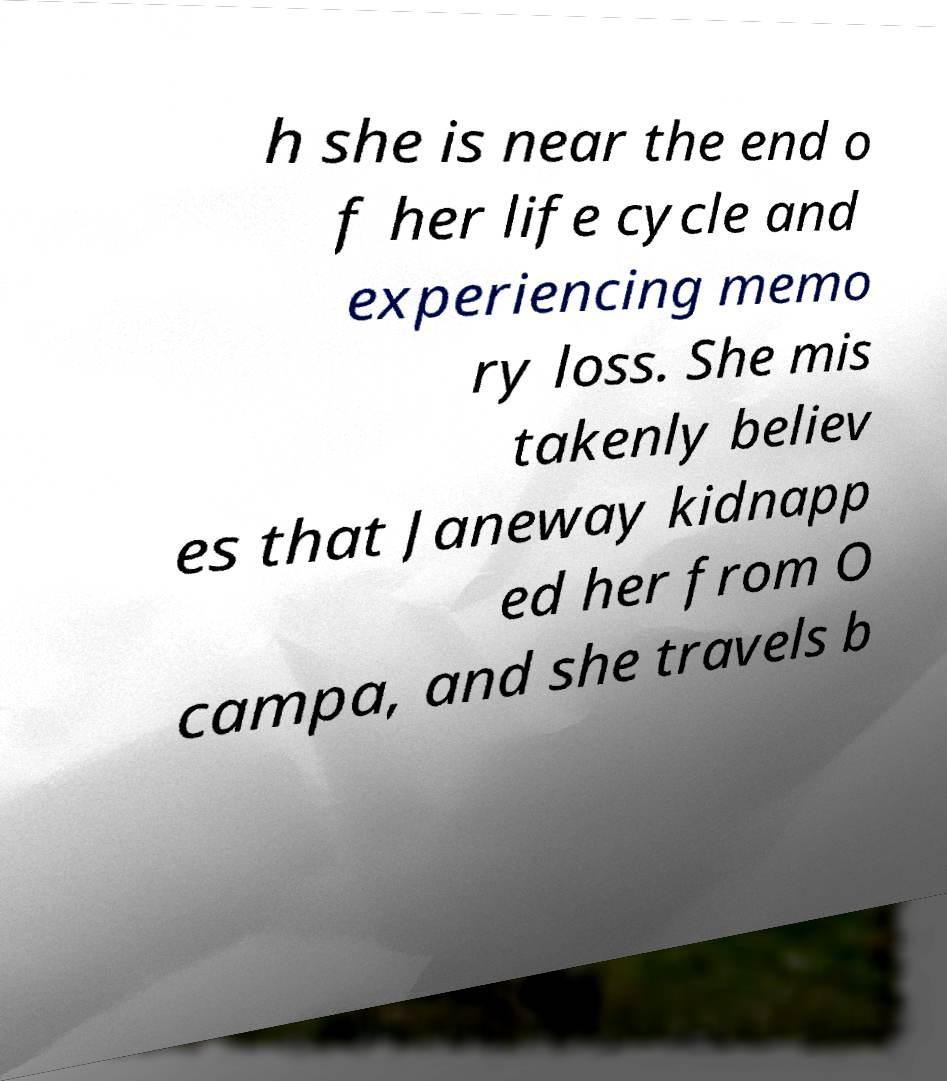Can you accurately transcribe the text from the provided image for me? h she is near the end o f her life cycle and experiencing memo ry loss. She mis takenly believ es that Janeway kidnapp ed her from O campa, and she travels b 